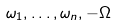Convert formula to latex. <formula><loc_0><loc_0><loc_500><loc_500>\omega _ { 1 } , \dots , \omega _ { n } , - \Omega</formula> 